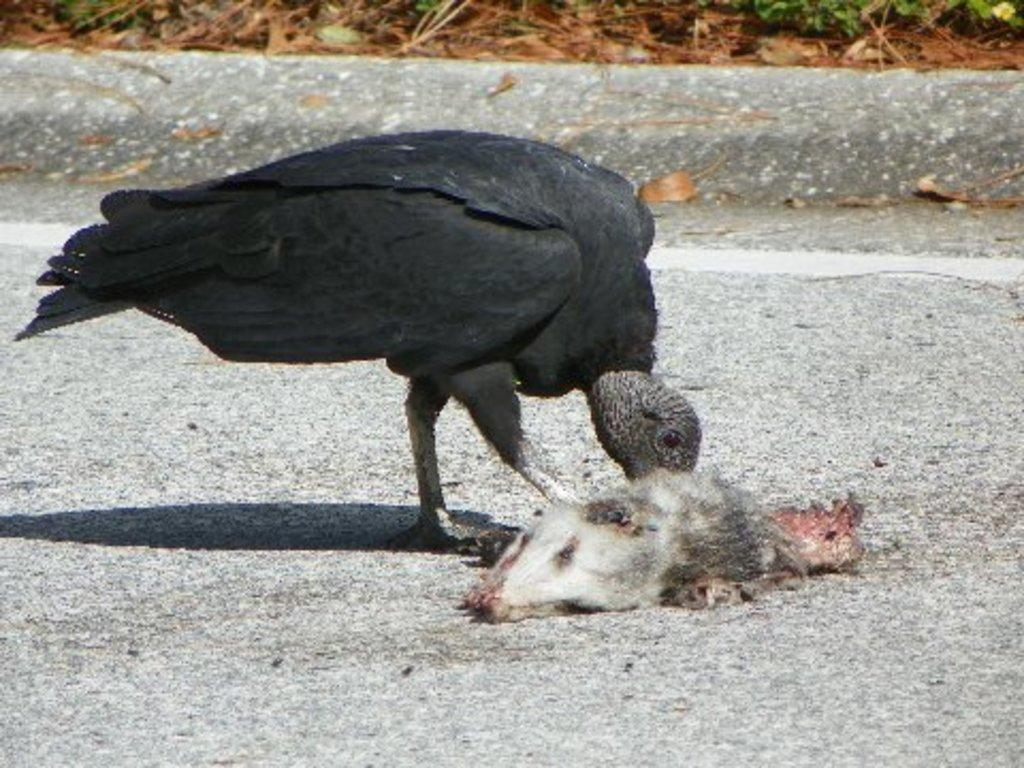What type of animal can be seen in the image? There is a bird in the image. What is the bird doing in the image? The bird is eating a dead animal. What can be seen in the background of the image? There are leaves and plants in the background of the image. Where is the lunchroom located in the image? There is no lunchroom present in the image. What type of match is being played in the image? There is no match being played in the image. 